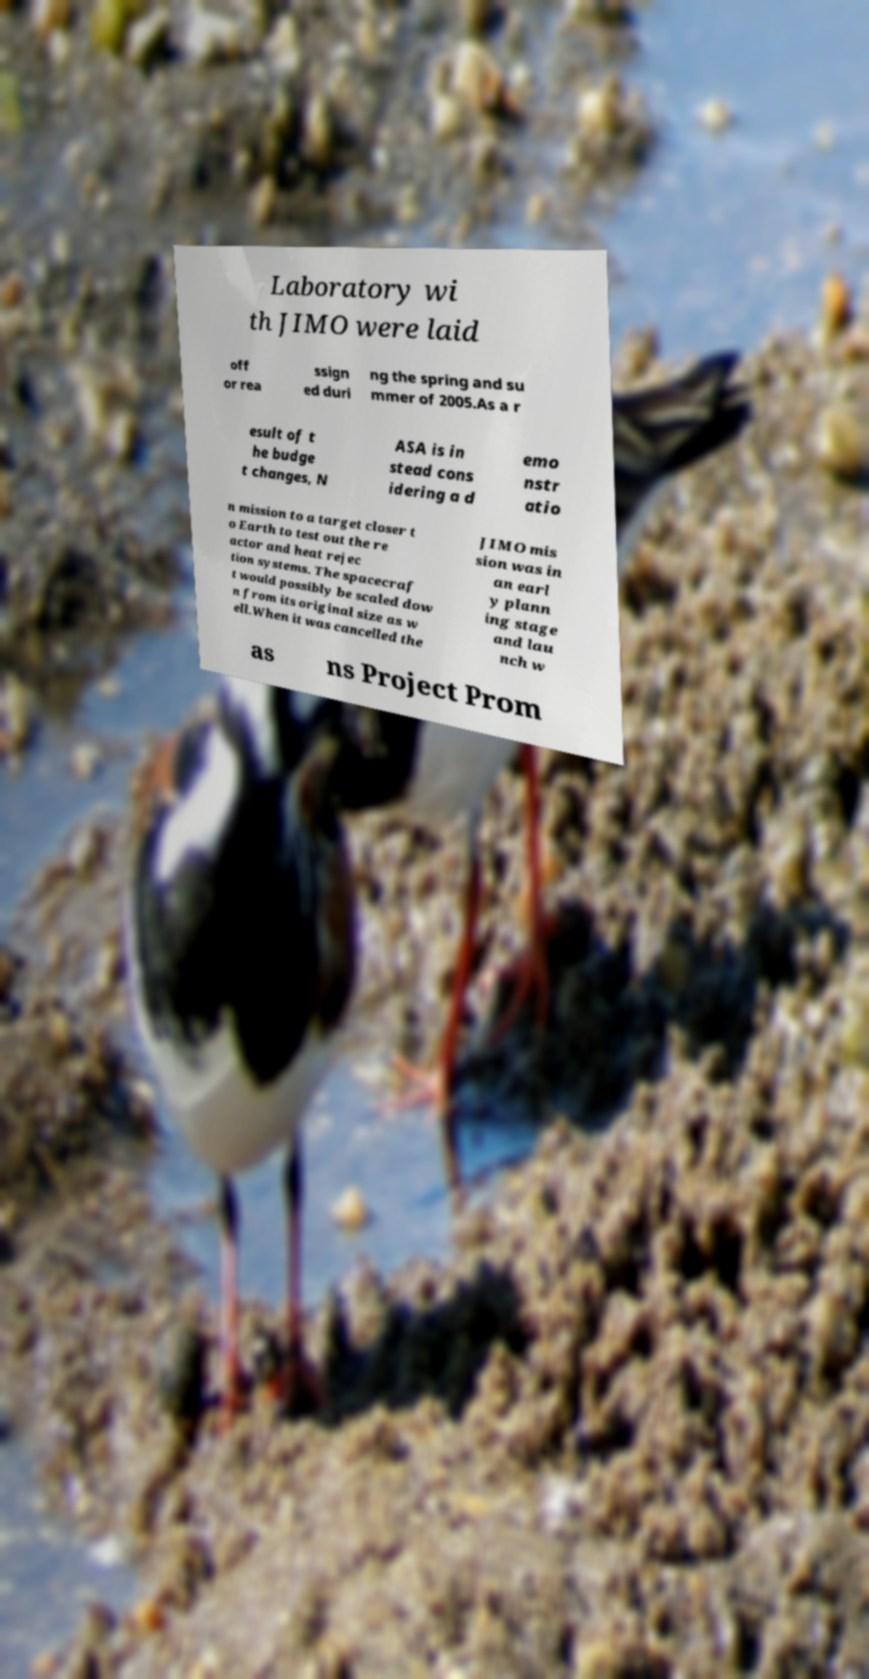I need the written content from this picture converted into text. Can you do that? Laboratory wi th JIMO were laid off or rea ssign ed duri ng the spring and su mmer of 2005.As a r esult of t he budge t changes, N ASA is in stead cons idering a d emo nstr atio n mission to a target closer t o Earth to test out the re actor and heat rejec tion systems. The spacecraf t would possibly be scaled dow n from its original size as w ell.When it was cancelled the JIMO mis sion was in an earl y plann ing stage and lau nch w as ns Project Prom 